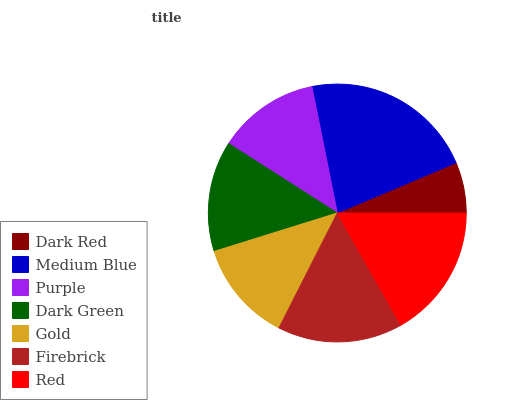Is Dark Red the minimum?
Answer yes or no. Yes. Is Medium Blue the maximum?
Answer yes or no. Yes. Is Purple the minimum?
Answer yes or no. No. Is Purple the maximum?
Answer yes or no. No. Is Medium Blue greater than Purple?
Answer yes or no. Yes. Is Purple less than Medium Blue?
Answer yes or no. Yes. Is Purple greater than Medium Blue?
Answer yes or no. No. Is Medium Blue less than Purple?
Answer yes or no. No. Is Dark Green the high median?
Answer yes or no. Yes. Is Dark Green the low median?
Answer yes or no. Yes. Is Red the high median?
Answer yes or no. No. Is Gold the low median?
Answer yes or no. No. 